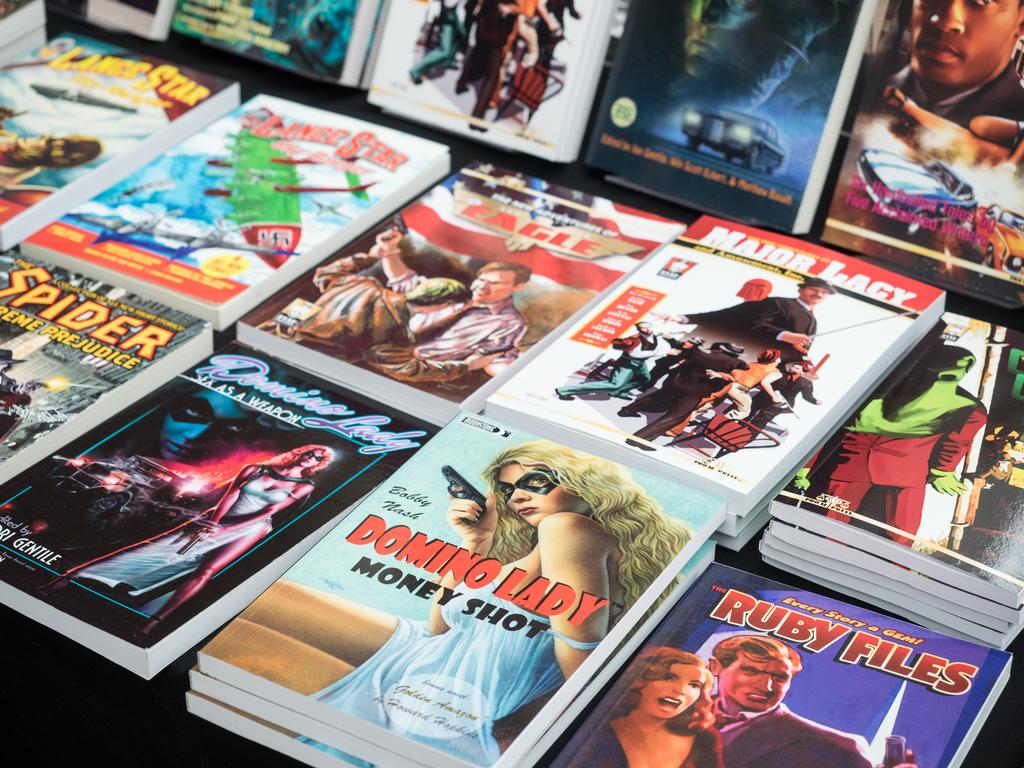<image>
Render a clear and concise summary of the photo. Several books being displayed on a table, one of which is Domino Lady 